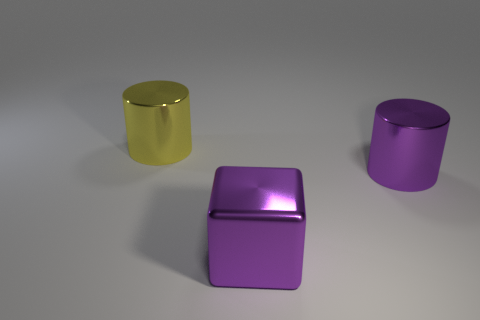Add 2 purple things. How many objects exist? 5 Subtract all yellow cylinders. How many cylinders are left? 1 Subtract all cylinders. How many objects are left? 1 Add 3 big yellow shiny cylinders. How many big yellow shiny cylinders exist? 4 Subtract 0 brown balls. How many objects are left? 3 Subtract all red cylinders. Subtract all gray cubes. How many cylinders are left? 2 Subtract all big cylinders. Subtract all small gray cylinders. How many objects are left? 1 Add 2 purple metal things. How many purple metal things are left? 4 